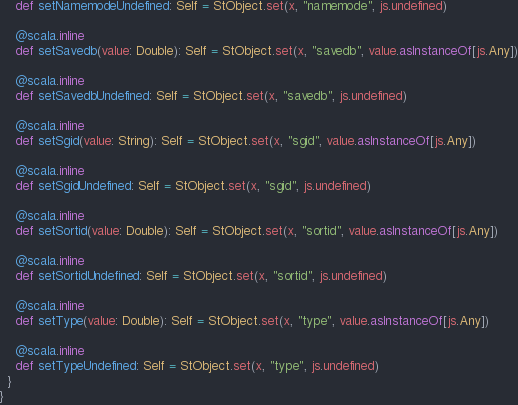<code> <loc_0><loc_0><loc_500><loc_500><_Scala_>    def setNamemodeUndefined: Self = StObject.set(x, "namemode", js.undefined)
    
    @scala.inline
    def setSavedb(value: Double): Self = StObject.set(x, "savedb", value.asInstanceOf[js.Any])
    
    @scala.inline
    def setSavedbUndefined: Self = StObject.set(x, "savedb", js.undefined)
    
    @scala.inline
    def setSgid(value: String): Self = StObject.set(x, "sgid", value.asInstanceOf[js.Any])
    
    @scala.inline
    def setSgidUndefined: Self = StObject.set(x, "sgid", js.undefined)
    
    @scala.inline
    def setSortid(value: Double): Self = StObject.set(x, "sortid", value.asInstanceOf[js.Any])
    
    @scala.inline
    def setSortidUndefined: Self = StObject.set(x, "sortid", js.undefined)
    
    @scala.inline
    def setType(value: Double): Self = StObject.set(x, "type", value.asInstanceOf[js.Any])
    
    @scala.inline
    def setTypeUndefined: Self = StObject.set(x, "type", js.undefined)
  }
}
</code> 